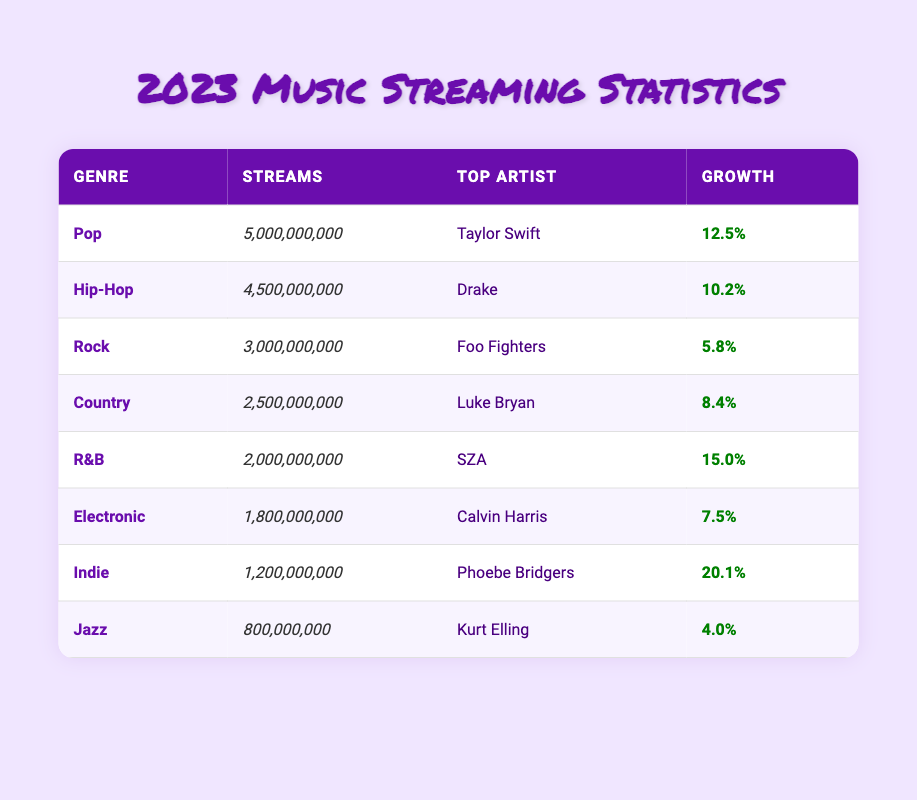What is the genre with the highest number of streams? According to the table, 'Pop' has the highest streams at 5,000,000,000, surpassing all other genres listed.
Answer: Pop Which artist is listed as the top artist in the R&B genre? The table indicates that 'SZA' is the top artist in the R&B genre.
Answer: SZA What percentage growth did the Electronic genre experience? The table shows that the percentage growth for the Electronic genre is 7.5%.
Answer: 7.5% What is the difference in streams between the Country and Indie genres? From the data, Country has 2,500,000,000 streams and Indie has 1,200,000,000 streams. The difference is 2,500,000,000 - 1,200,000,000 = 1,300,000,000.
Answer: 1,300,000,000 Is it true that Hip-Hop has more streams than R&B? Yes, Hip-Hop has 4,500,000,000 streams while R&B has 2,000,000,000, confirming that Hip-Hop has more streams.
Answer: Yes What is the average number of streams across all genres? To find the average, we first sum the streams: 5,000,000,000 + 4,500,000,000 + 3,000,000,000 + 2,500,000,000 + 2,000,000,000 + 1,800,000,000 + 1,200,000,000 + 800,000,000 = 21,800,000,000. Then, divide by the number of genres (8): 21,800,000,000 / 8 = 2,725,000,000.
Answer: 2,725,000,000 Which genre has the most percentage growth and what is that percentage? From the table, Indie has the highest percentage growth at 20.1%, indicating it has grown the most compared to other genres.
Answer: Indie, 20.1% How many genres have percentage growth greater than 10%? Referring to the table, Pop (12.5%), Hip-Hop (10.2%), R&B (15.0%), and Indie (20.1%) have percentage growth greater than 10%. This totals to 4 genres.
Answer: 4 What is the combined total number of streams for Pop and Rock? The streams for Pop are 5,000,000,000 and for Rock are 3,000,000,000. Adding these together gives: 5,000,000,000 + 3,000,000,000 = 8,000,000,000.
Answer: 8,000,000,000 